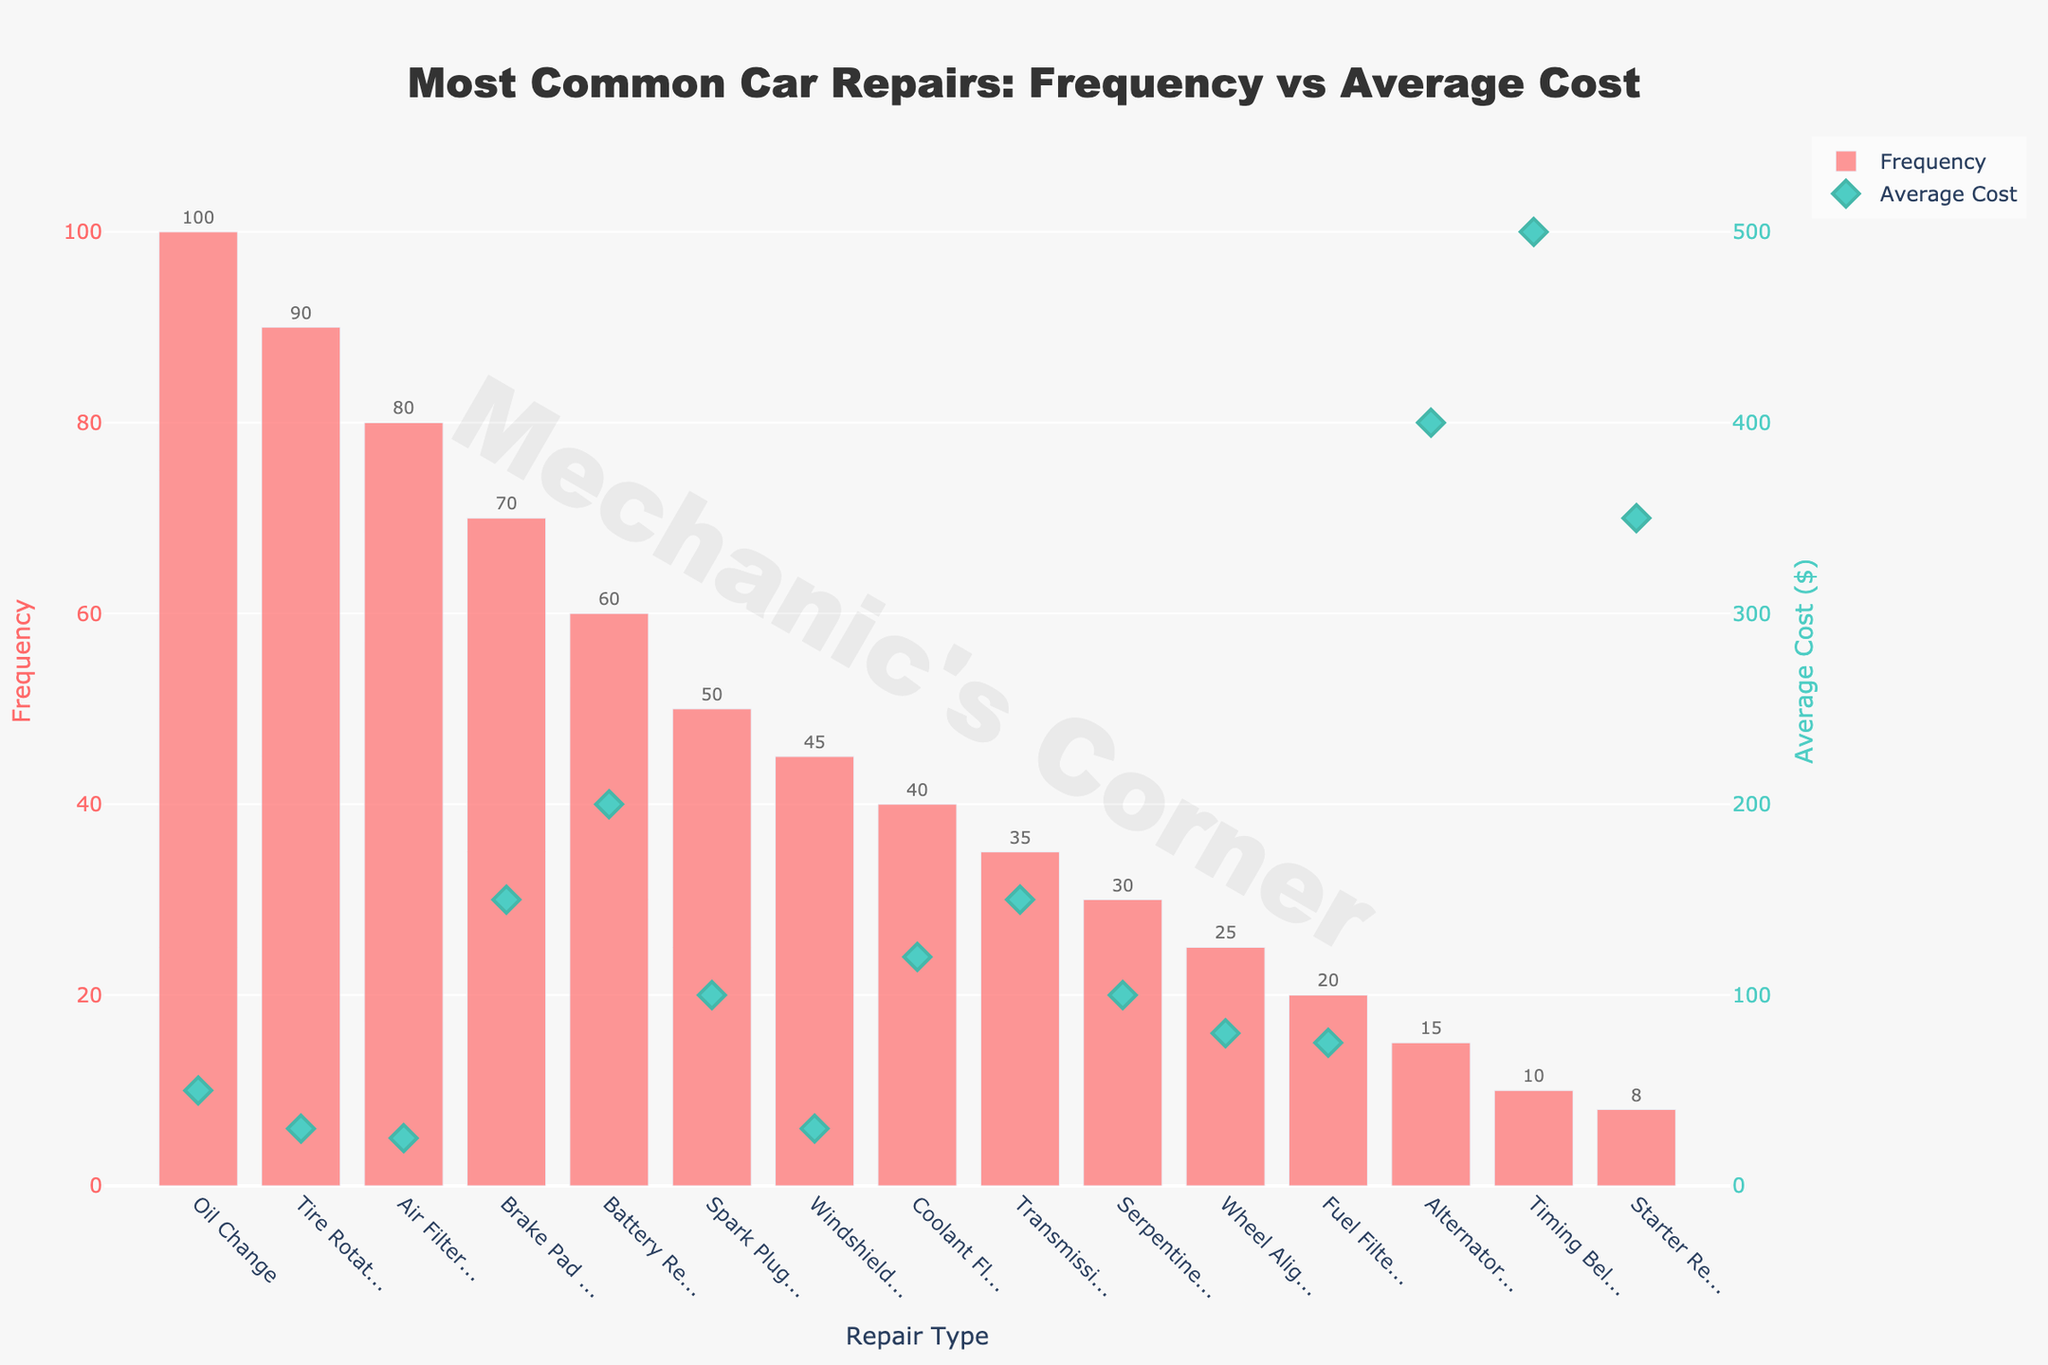What's the most frequent car repair? The figure shows multiple bars representing the frequency of car repairs. The highest bar represents the most frequent car repair. The "Oil Change" bar is the highest.
Answer: Oil Change Which car repair has the highest average cost? The figure has markers indicating the average cost of each repair. The highest marker corresponds to "Timing Belt Replacement" at $500.
Answer: Timing Belt Replacement What's the difference in average cost between a Brake Pad Replacement and an Alternator Replacement? The average cost markers indicate $150 for a Brake Pad Replacement and $400 for an Alternator Replacement. The difference is $400 - $150.
Answer: $250 Which has a higher frequency: Tire Rotation or Battery Replacement? The figure shows the frequency bars. Comparing "Tire Rotation" and "Battery Replacement," the former has a higher frequency (90 vs. 60).
Answer: Tire Rotation How many repairs have an average cost exceeding $100? The average cost markers show which repairs exceed $100. These include Brake Pad Replacement, Battery Replacement, Coolant Flush, Transmission Fluid Change, Serpentine Belt Replacement, Alternator Replacement, Timing Belt Replacement, and Starter Replacement. There are 8 such repairs.
Answer: 8 Which repair is both frequent (more than 50 times) and costly (more than $100)? Evaluating the frequency bars and average cost markers, two repairs meet the criteria: Brake Pad Replacement and Battery Replacement.
Answer: Brake Pad Replacement and Battery Replacement What's the total frequency of repairs with an average cost of $30? The figure has two repairs with an average cost of $30: "Tire Rotation" with a frequency of 90 and "Windshield Wiper Replacement" with a frequency of 45. Total frequency is 90 + 45.
Answer: 135 Which has a lower average cost: Spark Plug Replacement or Serpentine Belt Replacement? The average cost markers indicate $100 for both Spark Plug Replacement and Serpentine Belt Replacement. Hence, they have the same cost.
Answer: Same cost What is the combined frequency of the three least frequent repairs? The frequency bars for the three least frequent repairs show: Alternator Replacement (15), Timing Belt Replacement (10), and Starter Replacement (8). The combined frequency is 15 + 10 + 8.
Answer: 33 